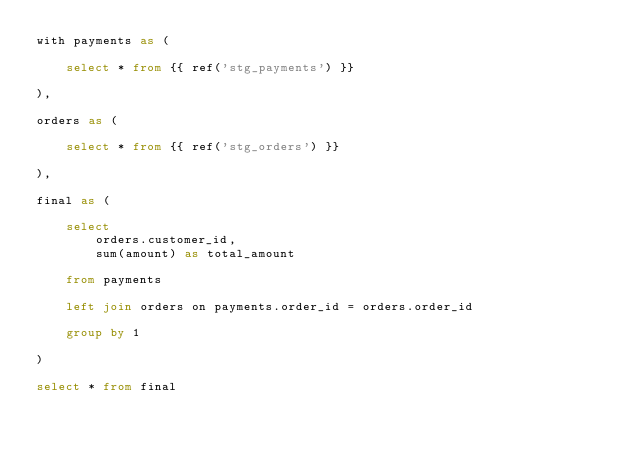Convert code to text. <code><loc_0><loc_0><loc_500><loc_500><_SQL_>with payments as (

    select * from {{ ref('stg_payments') }}

),

orders as (

    select * from {{ ref('stg_orders') }}

),

final as (

    select
        orders.customer_id,
        sum(amount) as total_amount

    from payments

    left join orders on payments.order_id = orders.order_id

    group by 1

)

select * from final
</code> 